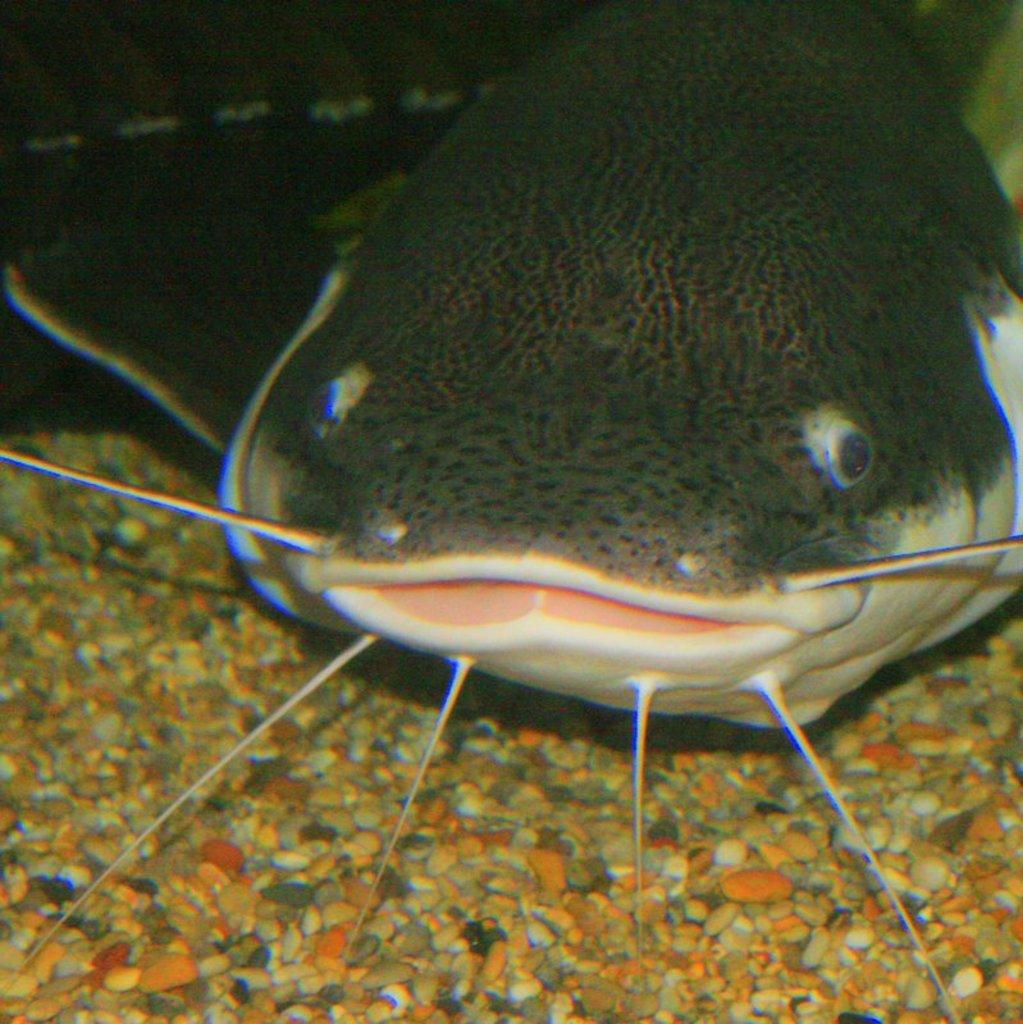What is the main subject of the image? The main subject of the image is a fish. What other objects can be seen in the image? There are stones visible in the image. What is the color of the background in the image? The background of the image is dark. Where is the prison located in the image? There is no prison present in the image. What type of jewel can be seen on the fish in the image? There is no jewel present on the fish in the image. 